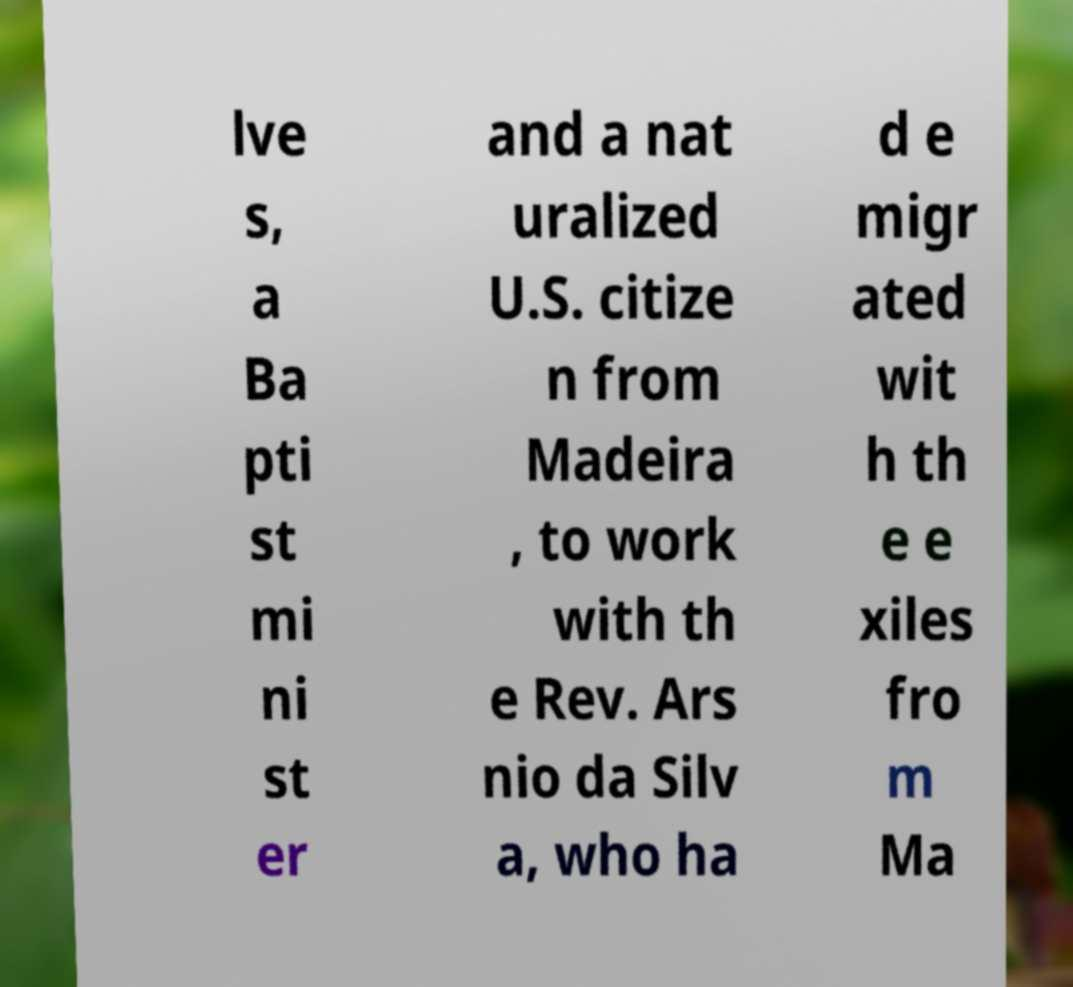Could you extract and type out the text from this image? lve s, a Ba pti st mi ni st er and a nat uralized U.S. citize n from Madeira , to work with th e Rev. Ars nio da Silv a, who ha d e migr ated wit h th e e xiles fro m Ma 